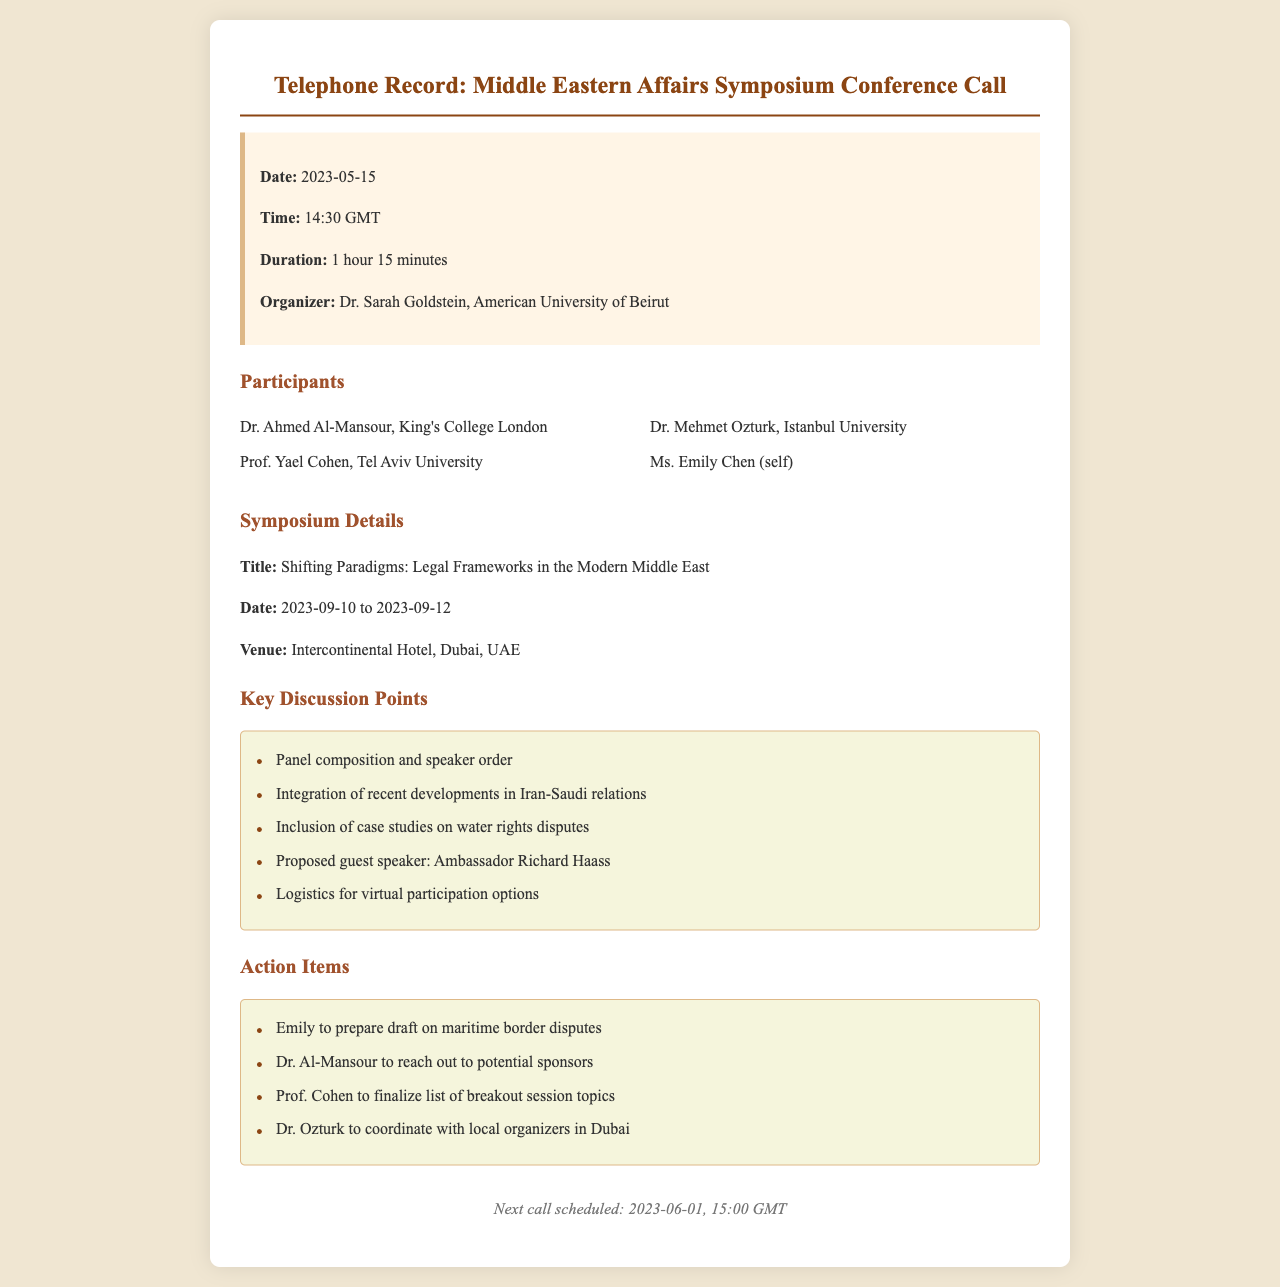What is the date of the conference call? The date of the conference call is explicitly mentioned in the call info section of the document.
Answer: 2023-05-15 Who organized the symposium? The organizer is listed in the call info section, along with her affiliation.
Answer: Dr. Sarah Goldstein, American University of Beirut How long was the conference call? The duration is provided in the call info section of the document.
Answer: 1 hour 15 minutes What is the title of the symposium? The title is stated under the symposium details section of the document.
Answer: Shifting Paradigms: Legal Frameworks in the Modern Middle East Name one participant from King's College London. The participants are listed with their respective institutions, including one from King's College London.
Answer: Dr. Ahmed Al-Mansour What was proposed as a guest speaker? The proposed guest speaker is mentioned in the key discussion points section.
Answer: Ambassador Richard Haass What is one action item for Dr. Ozturk? The action items specify tasks assigned to each participant, including Dr. Ozturk.
Answer: Coordinate with local organizers in Dubai What is the next scheduled call date? The next call date is found in the footer of the document.
Answer: 2023-06-01 How will virtual participation be handled? This is one of the logistics topics discussed in the key points section.
Answer: Logistics for virtual participation options 